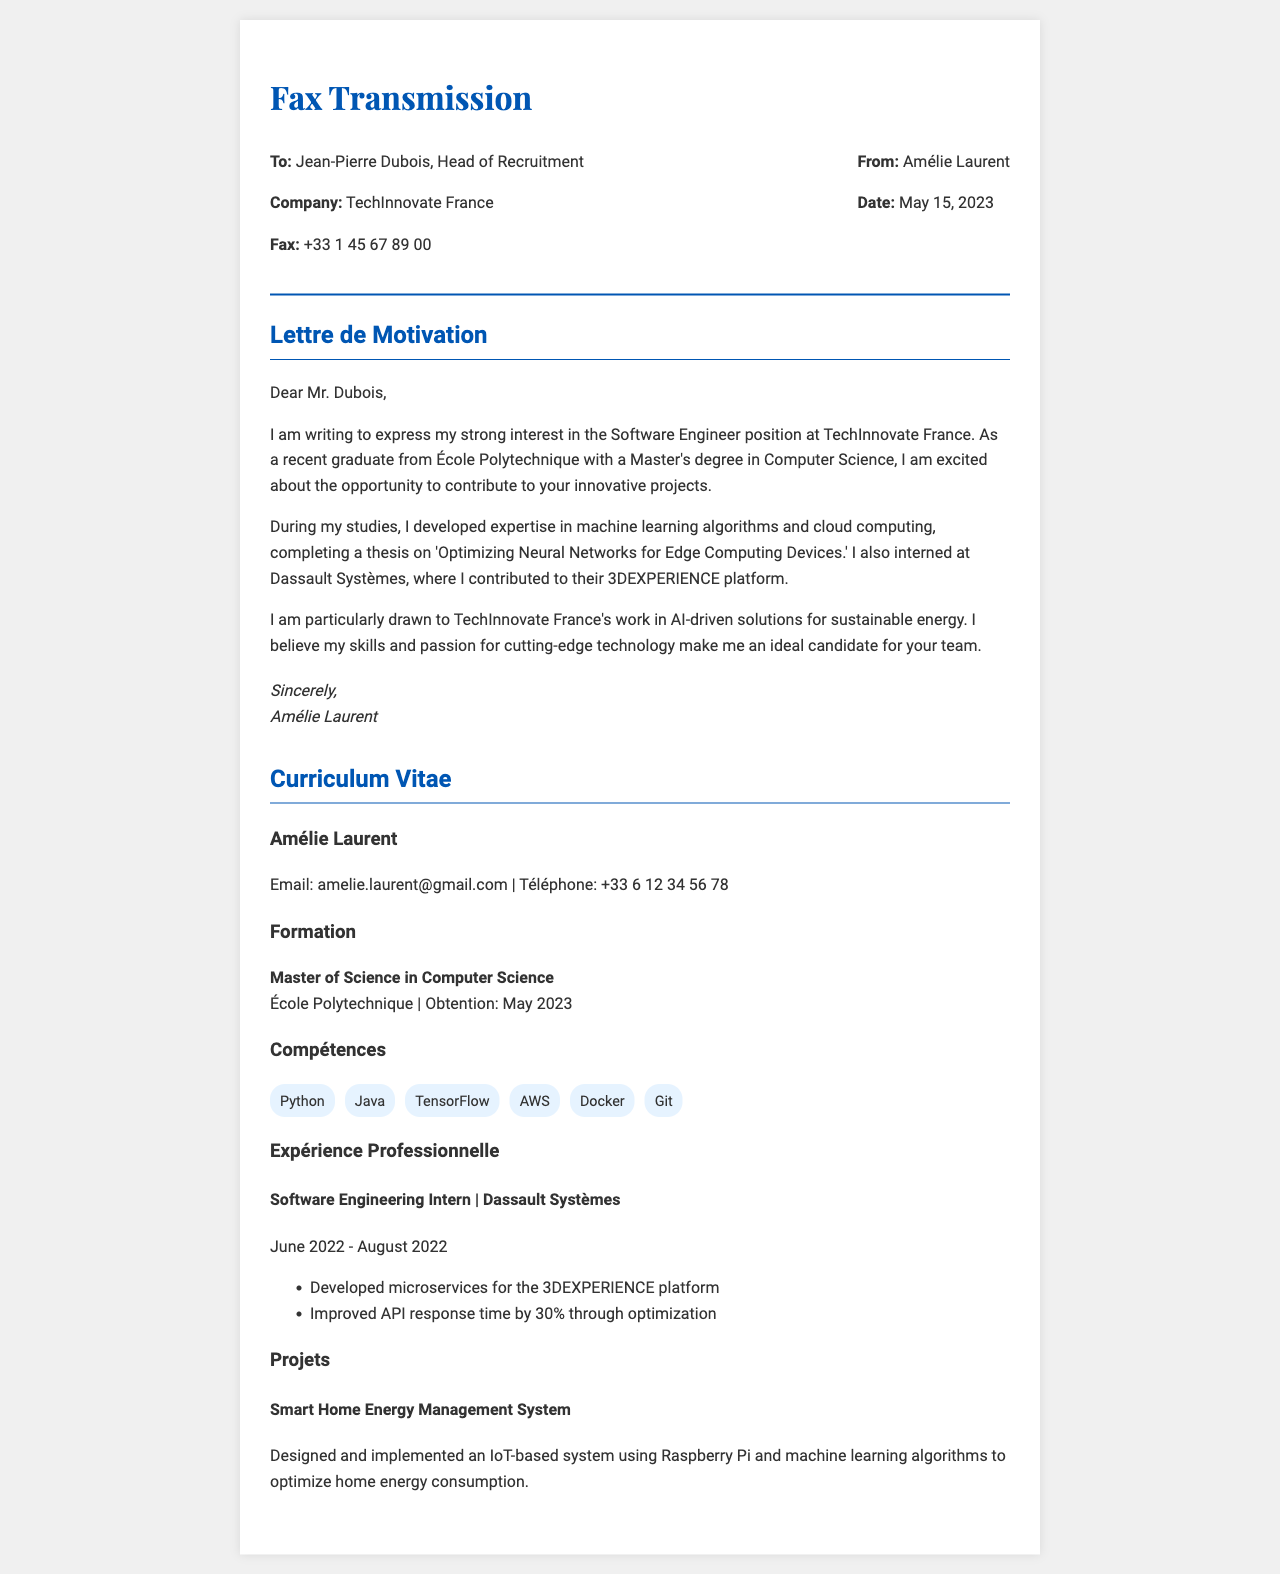What is the candidate's name? The name of the candidate who sent the fax is stated at the beginning of the correspondence.
Answer: Amélie Laurent What is the date of the fax? The date mentioned in the fax indicates when the document was sent.
Answer: May 15, 2023 Which university did the candidate graduate from? The resume section provides details about the candidate's educational background.
Answer: École Polytechnique What position is Amélie applying for? The cover letter specifies the job title for which the candidate is expressing interest.
Answer: Software Engineer How long did Amélie intern at Dassault Systèmes? The experience section gives the duration of Amélie's internship with the company.
Answer: 2 months What thesis topic did Amélie complete? The cover letter mentions the specific academic project that Amélie worked on during her studies.
Answer: Optimizing Neural Networks for Edge Computing Devices How many skills are listed in the resume? The skills section enumerates the competencies Amélie possesses, allowing us to count them directly from the list.
Answer: 6 skills What main technological area is TechInnovate France involved in? The cover letter refers to the specific field or focus of the company regarding its innovative projects.
Answer: AI-driven solutions for sustainable energy What task did Amélie perform to improve API performance? The experience section outlines specific improvements made during her internship.
Answer: Improved API response time by 30% 